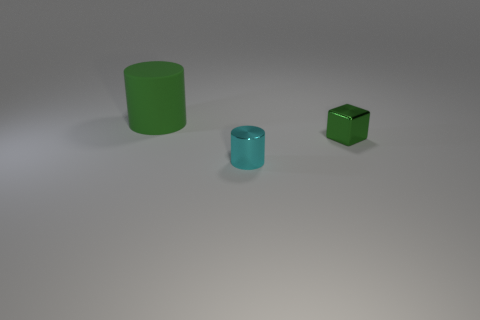Are there any other things that are the same size as the green matte thing?
Offer a terse response. No. There is a green metallic block; are there any big rubber cylinders behind it?
Provide a short and direct response. Yes. There is a small cube that is the same color as the large matte cylinder; what is it made of?
Make the answer very short. Metal. Do the green thing behind the tiny green block and the tiny cyan thing have the same material?
Provide a short and direct response. No. Are there any large cylinders that are in front of the small metal thing that is in front of the thing on the right side of the tiny cylinder?
Offer a very short reply. No. What number of blocks are either cyan metal things or green rubber objects?
Ensure brevity in your answer.  0. There is a cylinder right of the large cylinder; what is it made of?
Provide a short and direct response. Metal. The object that is the same color as the large matte cylinder is what size?
Your response must be concise. Small. Does the cylinder behind the tiny cyan metal object have the same color as the cylinder that is in front of the green matte cylinder?
Keep it short and to the point. No. What number of objects are brown things or metallic objects?
Offer a very short reply. 2. 